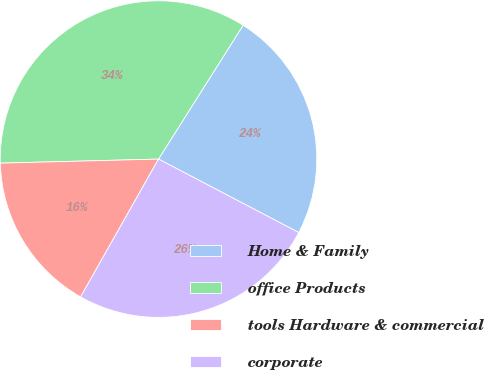<chart> <loc_0><loc_0><loc_500><loc_500><pie_chart><fcel>Home & Family<fcel>office Products<fcel>tools Hardware & commercial<fcel>corporate<nl><fcel>23.71%<fcel>34.38%<fcel>16.4%<fcel>25.51%<nl></chart> 